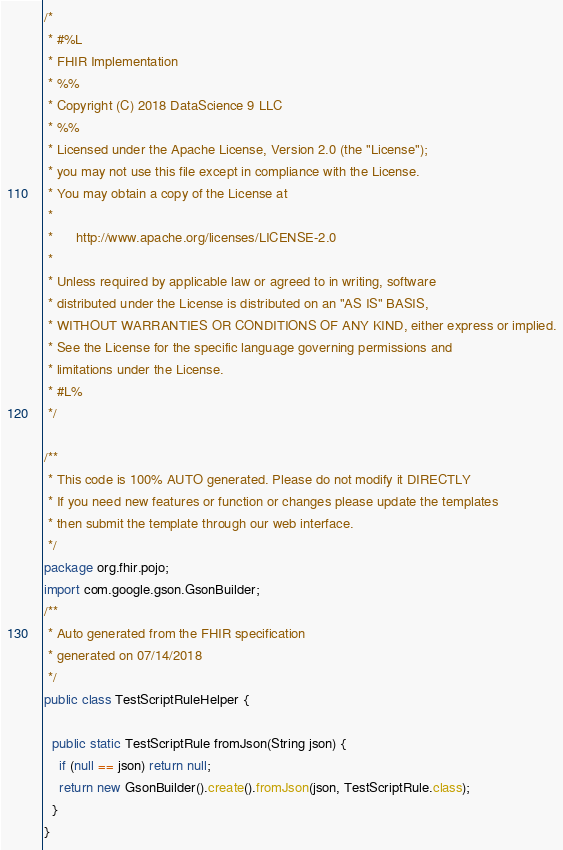Convert code to text. <code><loc_0><loc_0><loc_500><loc_500><_Java_>/*
 * #%L
 * FHIR Implementation
 * %%
 * Copyright (C) 2018 DataScience 9 LLC
 * %%
 * Licensed under the Apache License, Version 2.0 (the "License");
 * you may not use this file except in compliance with the License.
 * You may obtain a copy of the License at
 * 
 *      http://www.apache.org/licenses/LICENSE-2.0
 * 
 * Unless required by applicable law or agreed to in writing, software
 * distributed under the License is distributed on an "AS IS" BASIS,
 * WITHOUT WARRANTIES OR CONDITIONS OF ANY KIND, either express or implied.
 * See the License for the specific language governing permissions and
 * limitations under the License.
 * #L%
 */
 
/**
 * This code is 100% AUTO generated. Please do not modify it DIRECTLY
 * If you need new features or function or changes please update the templates
 * then submit the template through our web interface.  
 */
package org.fhir.pojo;
import com.google.gson.GsonBuilder;
/**
 * Auto generated from the FHIR specification
 * generated on 07/14/2018
 */
public class TestScriptRuleHelper {

  public static TestScriptRule fromJson(String json) {
    if (null == json) return null;
    return new GsonBuilder().create().fromJson(json, TestScriptRule.class);
  }
}</code> 